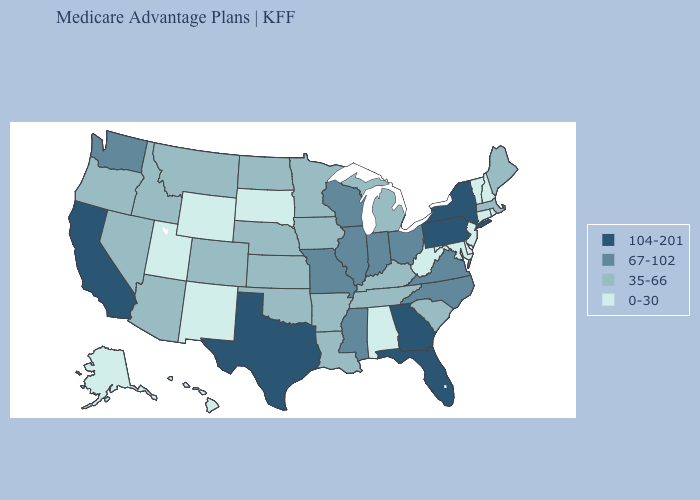Does Tennessee have the highest value in the South?
Be succinct. No. How many symbols are there in the legend?
Give a very brief answer. 4. Does Georgia have the highest value in the USA?
Write a very short answer. Yes. What is the value of Minnesota?
Quick response, please. 35-66. Does the first symbol in the legend represent the smallest category?
Quick response, please. No. What is the lowest value in states that border Nevada?
Concise answer only. 0-30. Does California have the highest value in the USA?
Write a very short answer. Yes. What is the value of Montana?
Give a very brief answer. 35-66. What is the value of Maryland?
Quick response, please. 0-30. What is the highest value in the USA?
Be succinct. 104-201. Among the states that border Missouri , does Kansas have the highest value?
Answer briefly. No. Does Tennessee have a lower value than Delaware?
Give a very brief answer. No. Does New Mexico have the highest value in the West?
Be succinct. No. Name the states that have a value in the range 104-201?
Concise answer only. California, Florida, Georgia, New York, Pennsylvania, Texas. Does the map have missing data?
Short answer required. No. 